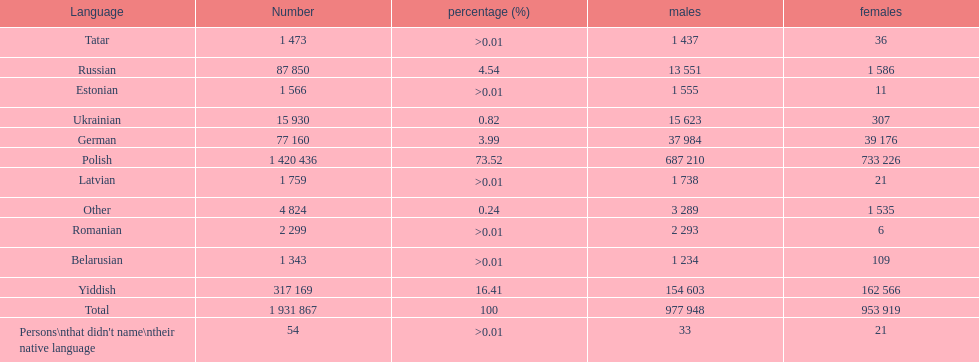Which language had the most number of people speaking it. Polish. 